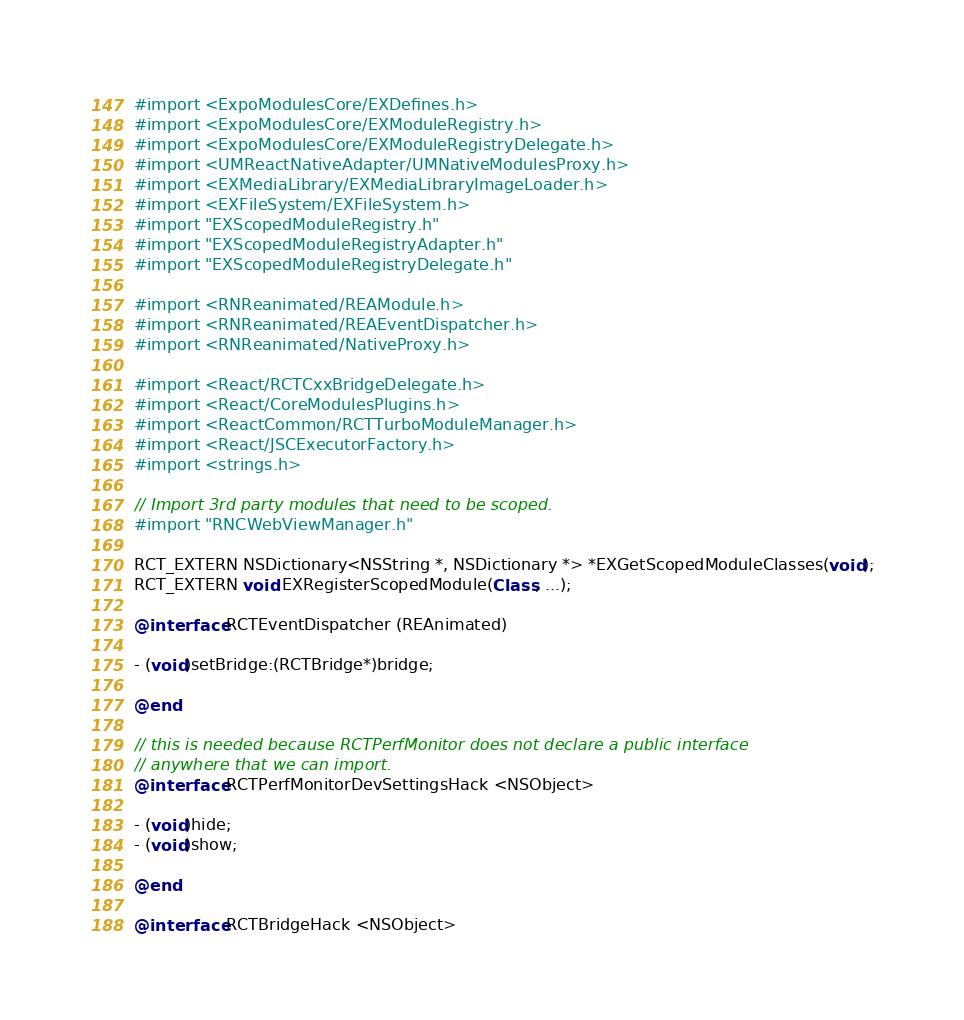<code> <loc_0><loc_0><loc_500><loc_500><_ObjectiveC_>
#import <ExpoModulesCore/EXDefines.h>
#import <ExpoModulesCore/EXModuleRegistry.h>
#import <ExpoModulesCore/EXModuleRegistryDelegate.h>
#import <UMReactNativeAdapter/UMNativeModulesProxy.h>
#import <EXMediaLibrary/EXMediaLibraryImageLoader.h>
#import <EXFileSystem/EXFileSystem.h>
#import "EXScopedModuleRegistry.h"
#import "EXScopedModuleRegistryAdapter.h"
#import "EXScopedModuleRegistryDelegate.h"

#import <RNReanimated/REAModule.h>
#import <RNReanimated/REAEventDispatcher.h>
#import <RNReanimated/NativeProxy.h>

#import <React/RCTCxxBridgeDelegate.h>
#import <React/CoreModulesPlugins.h>
#import <ReactCommon/RCTTurboModuleManager.h>
#import <React/JSCExecutorFactory.h>
#import <strings.h>

// Import 3rd party modules that need to be scoped.
#import "RNCWebViewManager.h"

RCT_EXTERN NSDictionary<NSString *, NSDictionary *> *EXGetScopedModuleClasses(void);
RCT_EXTERN void EXRegisterScopedModule(Class, ...);

@interface RCTEventDispatcher (REAnimated)

- (void)setBridge:(RCTBridge*)bridge;

@end

// this is needed because RCTPerfMonitor does not declare a public interface
// anywhere that we can import.
@interface RCTPerfMonitorDevSettingsHack <NSObject>

- (void)hide;
- (void)show;

@end

@interface RCTBridgeHack <NSObject>
</code> 